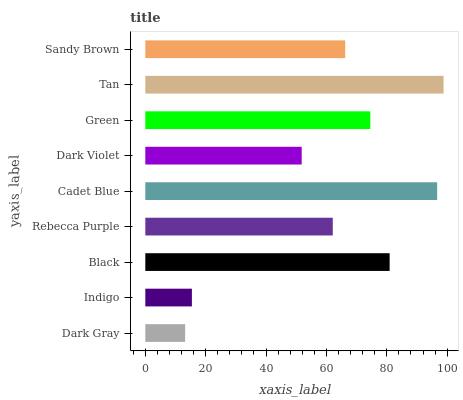Is Dark Gray the minimum?
Answer yes or no. Yes. Is Tan the maximum?
Answer yes or no. Yes. Is Indigo the minimum?
Answer yes or no. No. Is Indigo the maximum?
Answer yes or no. No. Is Indigo greater than Dark Gray?
Answer yes or no. Yes. Is Dark Gray less than Indigo?
Answer yes or no. Yes. Is Dark Gray greater than Indigo?
Answer yes or no. No. Is Indigo less than Dark Gray?
Answer yes or no. No. Is Sandy Brown the high median?
Answer yes or no. Yes. Is Sandy Brown the low median?
Answer yes or no. Yes. Is Black the high median?
Answer yes or no. No. Is Green the low median?
Answer yes or no. No. 